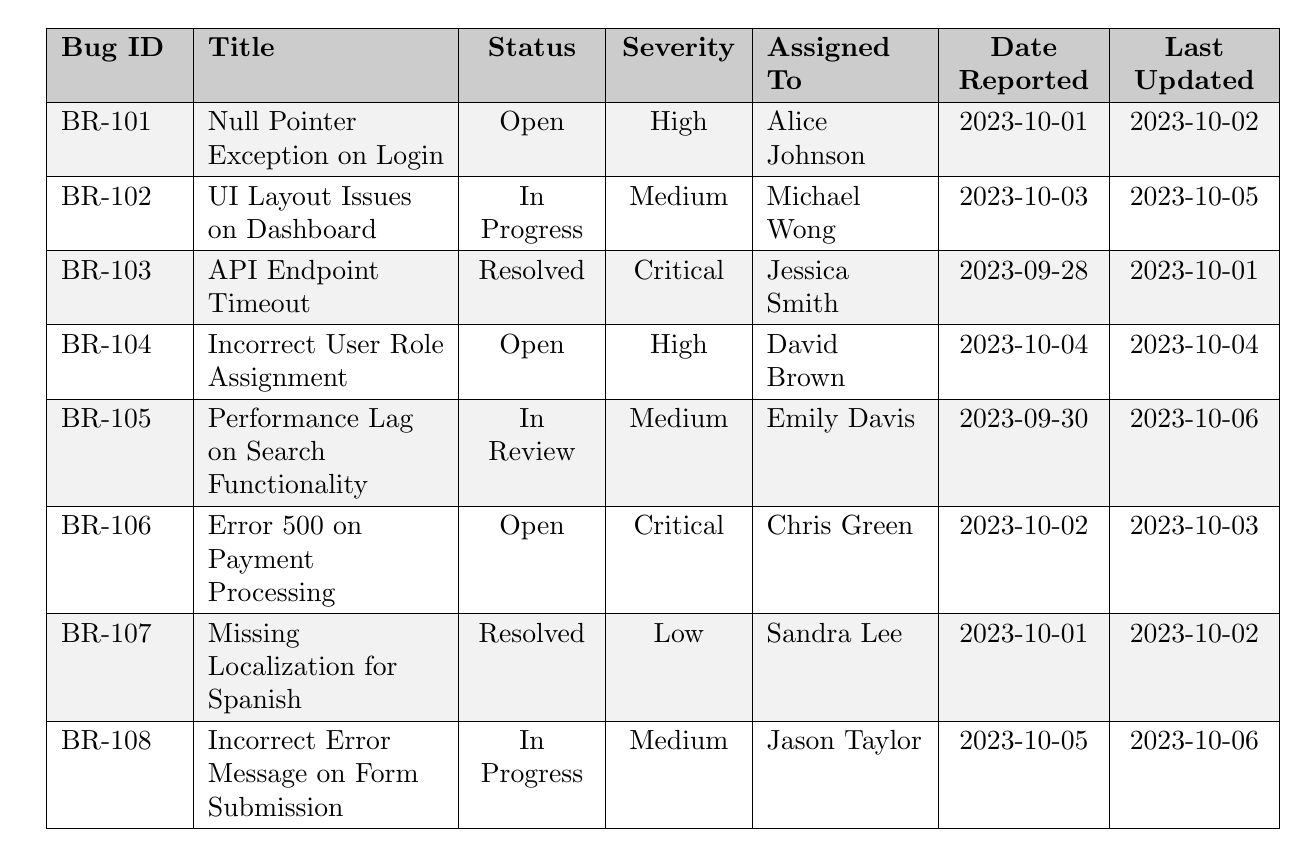What is the status of bug BR-101? The status is found in the third column of the row corresponding to bug BR-101; it shows "Open".
Answer: Open Who is assigned to the bug with the title "Performance Lag on Search Functionality"? In the row for "Performance Lag on Search Functionality", the assigned person is listed in the fifth column, which is "Emily Davis".
Answer: Emily Davis How many bugs are currently resolved? By looking at the table, I observe the status of each bug; two entries show "Resolved" in the status column (BR-103 and BR-107).
Answer: 2 What is the severity level of the bug recorded on 2023-10-03? The bug reported on 2023-10-03 corresponds to bug BR-102, which shows a severity of "Medium" in the fourth column.
Answer: Medium Is there a bug assigned to Chris Green? Yes, in the table, there is a bug (BR-106) assigned to Chris Green, as indicated in the fifth column.
Answer: Yes What is the difference in severity between the highest and lowest severity bugs? The highest severity bug is "Critical" (two entries), while the lowest is "Low" (one entry). If we categorize severity as numeric values (Critical=3, High=2, Medium=1, Low=0), the difference would be 3 - 0 = 3.
Answer: 3 Which bug has the latest last updated date? In the last updated column, the most recent date is 2023-10-06, which corresponds to bug BR-105 and BR-108. However, BR-108 is the first one listed in the corresponding row, so it is the latest one documented.
Answer: BR-108 Are there any bugs that are both open and have a high severity level? There are two entries marked as "Open" with a severity level of "High" (BR-101 and BR-104). Therefore, the answer is yes.
Answer: Yes How many bugs are currently in progress? From the table, I can see two entries with the status "In Progress" (BR-102 and BR-108), which indicates that there are two bugs in this status.
Answer: 2 Which bug was resolved the earliest based on the date reported? I need to compare the reported dates of the resolved bugs (BR-103 and BR-107), which were reported on 2023-09-28 and 2023-10-01 respectively. The earliest is BR-103, reported on 2023-09-28.
Answer: BR-103 What is the most common status of the bugs in the table? Counting the statuses from the table, "Open" appears 3 times, "In Progress" twice, "Resolved" twice, and "In Review" once. The most common status is "Open".
Answer: Open 